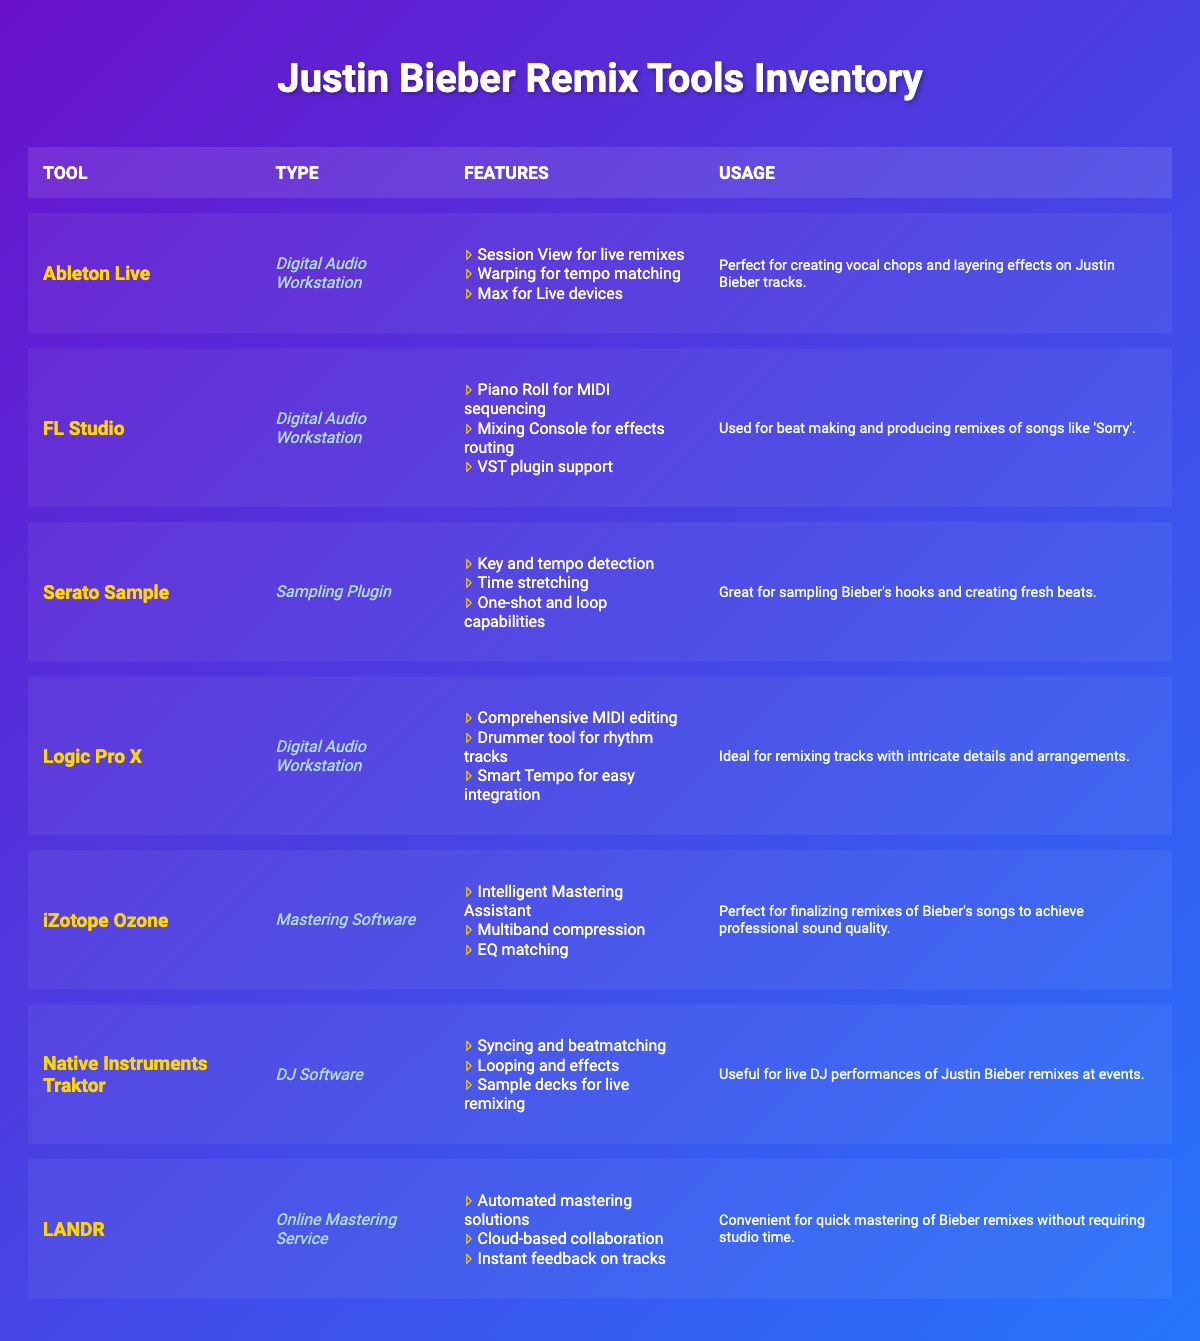What is the type of the tool "FL Studio"? The tool "FL Studio" is listed in the second row of the table under the "Type" column. It is categorized as a "Digital Audio Workstation."
Answer: Digital Audio Workstation Which tool is ideal for live remixes? According to the table, the features of "Ableton Live," specifically its "Session View for live remixes," indicate that it is ideal for this purpose.
Answer: Ableton Live Are there any sampling plugins in the inventory? The table shows that "Serato Sample" is listed as a "Sampling Plugin," confirming that there is at least one sampling plugin in the inventory.
Answer: Yes How many Digital Audio Workstations are mentioned in the inventory? The inventory includes three Digital Audio Workstations: "Ableton Live," "FL Studio," and "Logic Pro X." Counting these gives a total of three.
Answer: 3 What features does "iZotope Ozone" provide? Referring to the table, "iZotope Ozone" includes the following features: "Intelligent Mastering Assistant," "Multiband compression," and "EQ matching." These are explicitly listed in the inventory.
Answer: Intelligent Mastering Assistant, Multiband compression, EQ matching Which tool is used for quick mastering of Bieber remixes? The description of "LANDR" indicates its usage for quick mastering of Bieber remixes, highlighting its automated solutions and cloud-based capabilities.
Answer: LANDR What is the purpose of the "Native Instruments Traktor"? The table notes that "Native Instruments Traktor" is useful for live DJ performances, particularly for remixing Justin Bieber songs at events, indicating its primary purpose.
Answer: Live DJ performances Which tool has features for tempo matching? The features of "Ableton Live" include "Warping for tempo matching," thus identifying it as a tool that provides this capability.
Answer: Ableton Live List the usage of "Logic Pro X." According to the table, the usage of "Logic Pro X" is "Ideal for remixing tracks with intricate details and arrangements," summarizing its purpose in the inventory.
Answer: Ideal for remixing tracks with intricate details and arrangements 